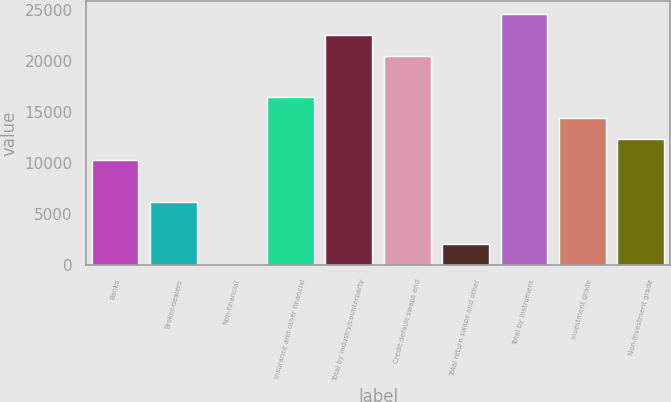Convert chart to OTSL. <chart><loc_0><loc_0><loc_500><loc_500><bar_chart><fcel>Banks<fcel>Broker-dealers<fcel>Non-financial<fcel>Insurance and other financial<fcel>Total by industry/counterparty<fcel>Credit default swaps and<fcel>Total return swaps and other<fcel>Total by instrument<fcel>Investment grade<fcel>Non-investment grade<nl><fcel>10302<fcel>6209.2<fcel>70<fcel>16441.2<fcel>22580.4<fcel>20534<fcel>2116.4<fcel>24626.8<fcel>14394.8<fcel>12348.4<nl></chart> 